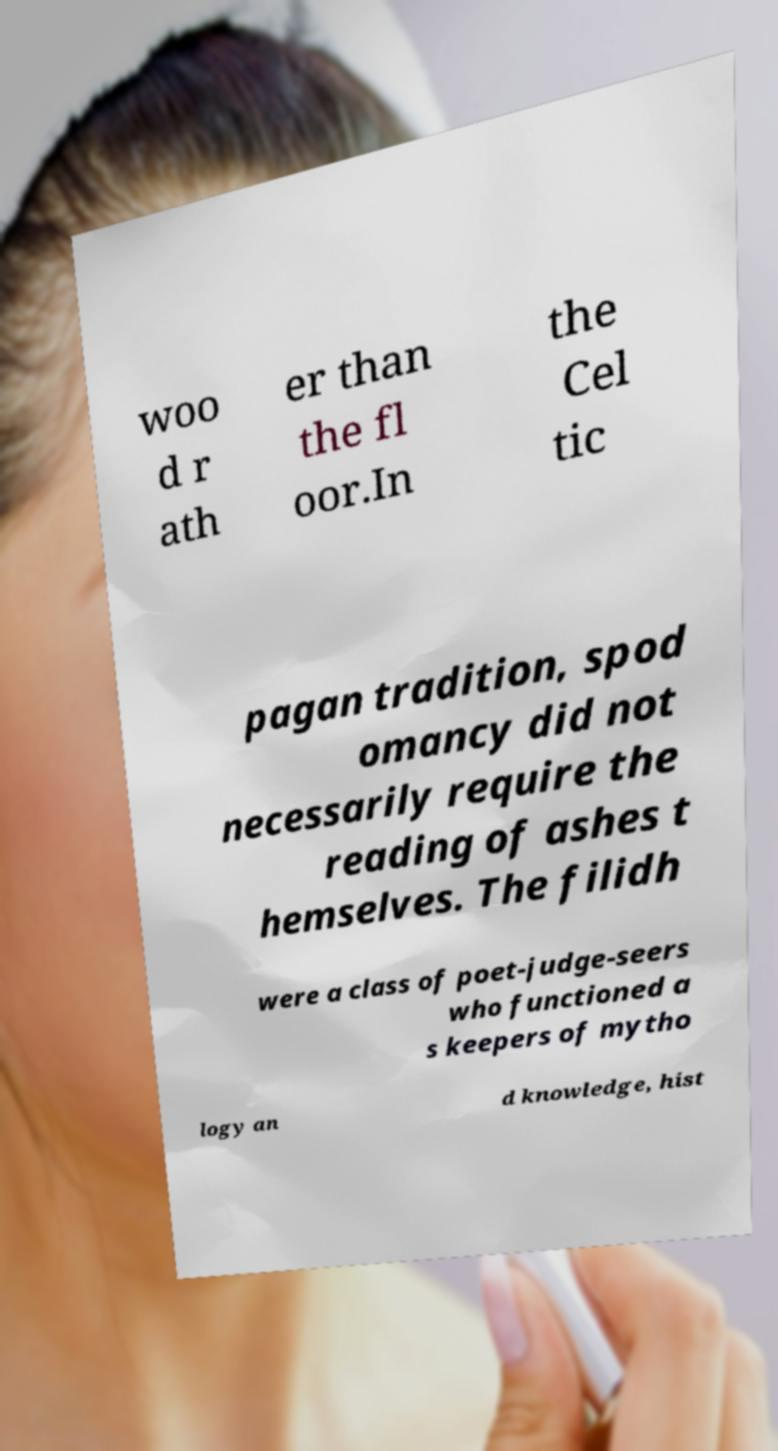Could you assist in decoding the text presented in this image and type it out clearly? woo d r ath er than the fl oor.In the Cel tic pagan tradition, spod omancy did not necessarily require the reading of ashes t hemselves. The filidh were a class of poet-judge-seers who functioned a s keepers of mytho logy an d knowledge, hist 